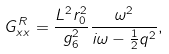Convert formula to latex. <formula><loc_0><loc_0><loc_500><loc_500>G ^ { R } _ { x x } = \frac { L ^ { 2 } r ^ { 2 } _ { 0 } } { g ^ { 2 } _ { 6 } } \frac { \omega ^ { 2 } } { i \omega - \frac { 1 } { 2 } q ^ { 2 } } ,</formula> 